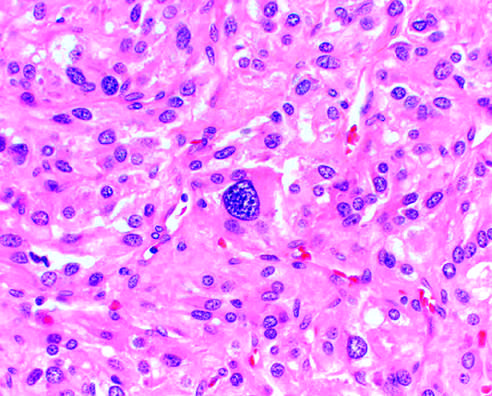what is seen (lower portion)?
Answer the question using a single word or phrase. The comma-shaped residual adrenal gland 